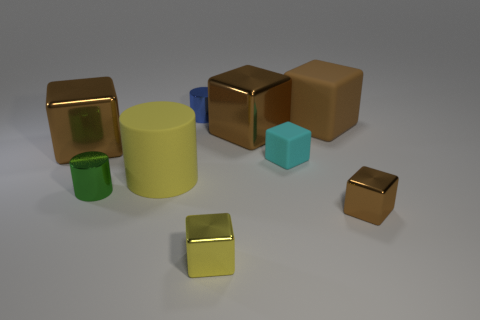There is a brown cube that is to the right of the small cyan object and behind the small rubber cube; what is its material? rubber 